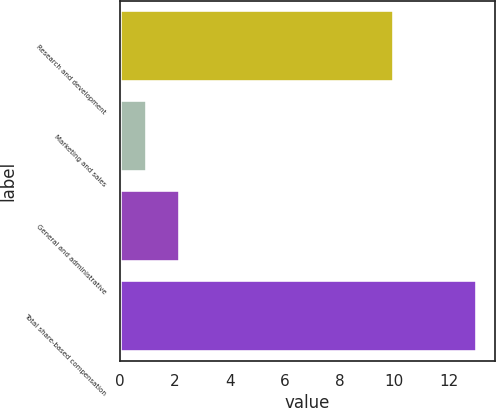<chart> <loc_0><loc_0><loc_500><loc_500><bar_chart><fcel>Research and development<fcel>Marketing and sales<fcel>General and administrative<fcel>Total share-based compensation<nl><fcel>10<fcel>1<fcel>2.2<fcel>13<nl></chart> 